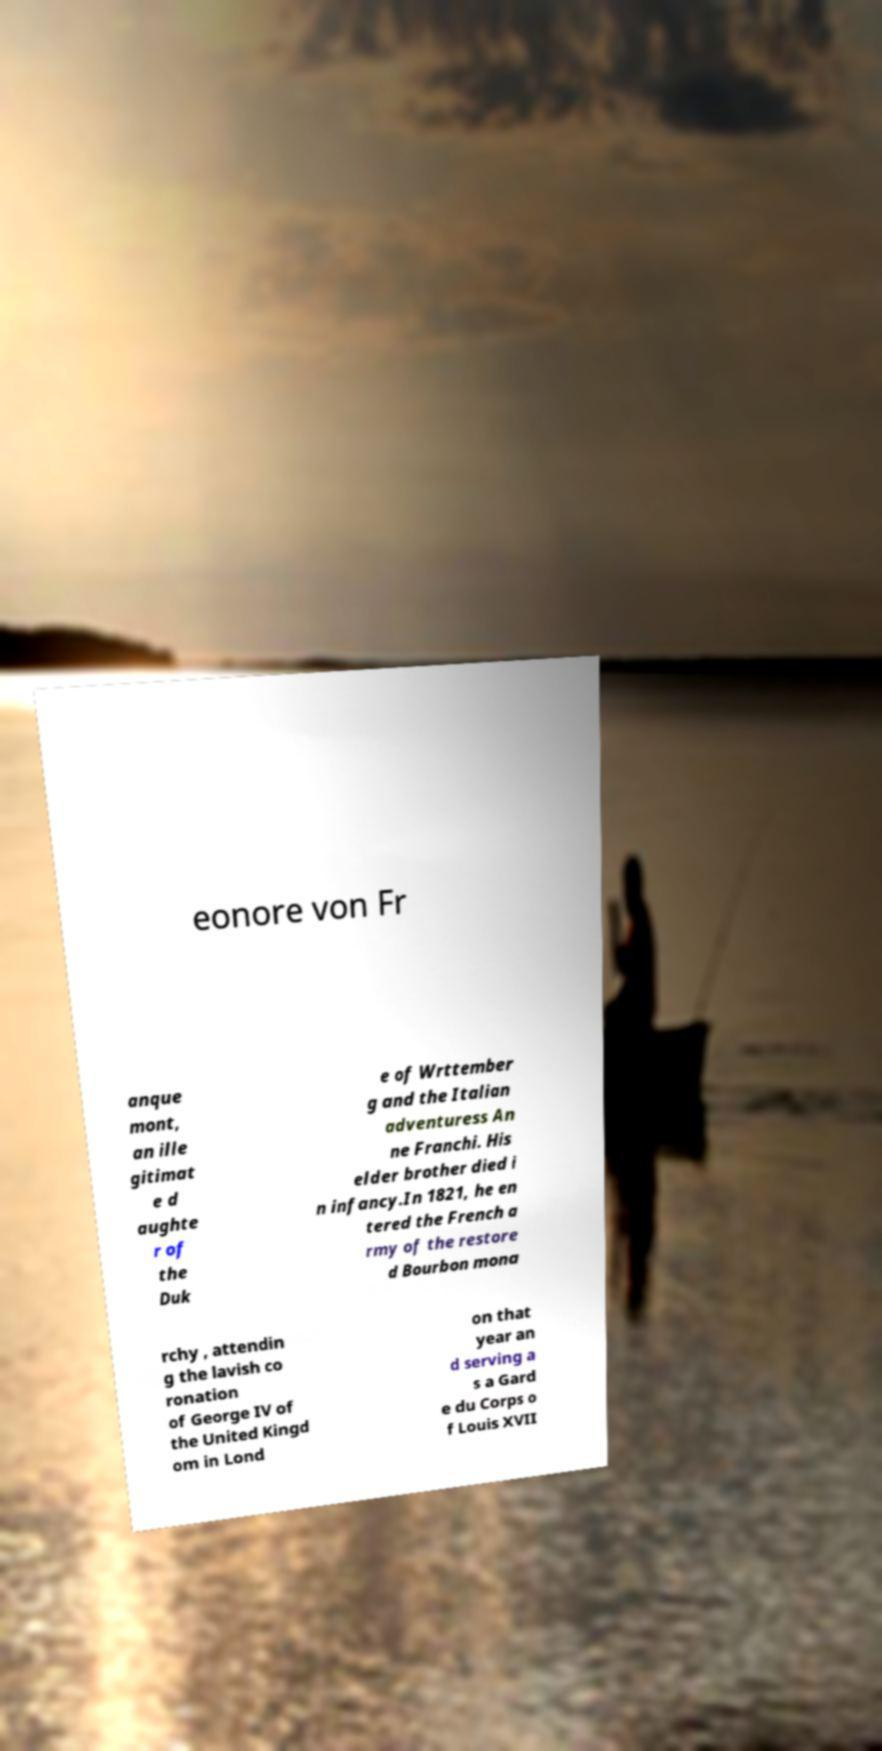Please identify and transcribe the text found in this image. eonore von Fr anque mont, an ille gitimat e d aughte r of the Duk e of Wrttember g and the Italian adventuress An ne Franchi. His elder brother died i n infancy.In 1821, he en tered the French a rmy of the restore d Bourbon mona rchy , attendin g the lavish co ronation of George IV of the United Kingd om in Lond on that year an d serving a s a Gard e du Corps o f Louis XVII 